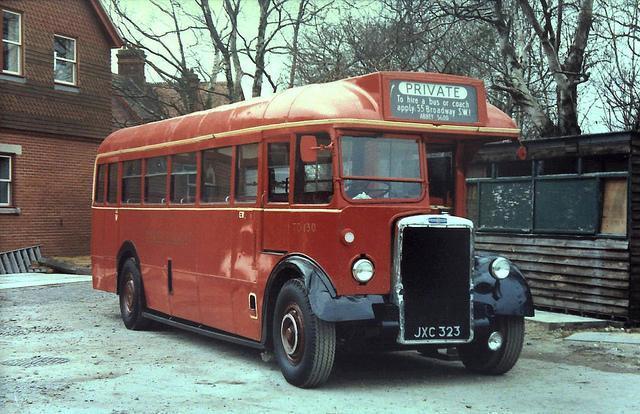How many buses are there?
Give a very brief answer. 1. 